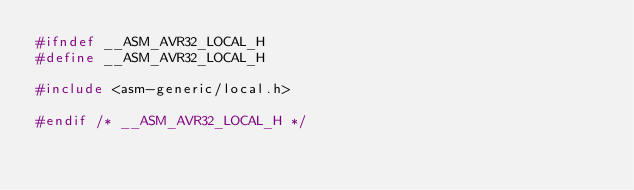Convert code to text. <code><loc_0><loc_0><loc_500><loc_500><_C_>#ifndef __ASM_AVR32_LOCAL_H
#define __ASM_AVR32_LOCAL_H

#include <asm-generic/local.h>

#endif /* __ASM_AVR32_LOCAL_H */
</code> 